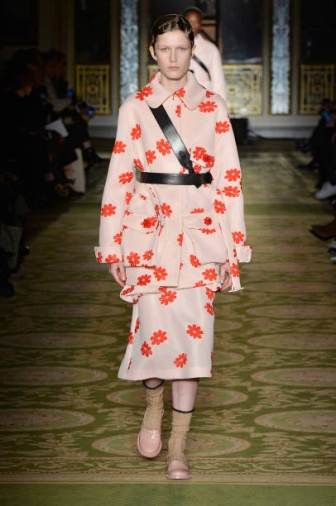If you were to design a room inspired by this fashion show, what elements would you include? Designing a room inspired by this fashion show would involve incorporating vibrant and contrasting colors, luxurious details, and unique accessories. The walls could be a soft, pastel pink, decorated with intricate red floral patterns. Gold accents on furniture and lighting fixtures would add an opulent touch, mirroring the ornate gold details of the room in the image.

The centerpiece of the room could be a plush green carpet, reminiscent of the runway, with comfortable seating arrangements flanked on either side to mimic the audience setup. A mix of contemporary and vintage furniture would create a dynamic space, highlighting the blend of modern fashion and classic elegance.

For additional flair, quirky elements like patterned throw pillows or unexpected accessories, such as a vibrant floral display or unique artwork, would draw attention and add character to the room. An overall sense of luxury, creativity, and boldness would permeate the design, capturing the essence of the fashion show. 